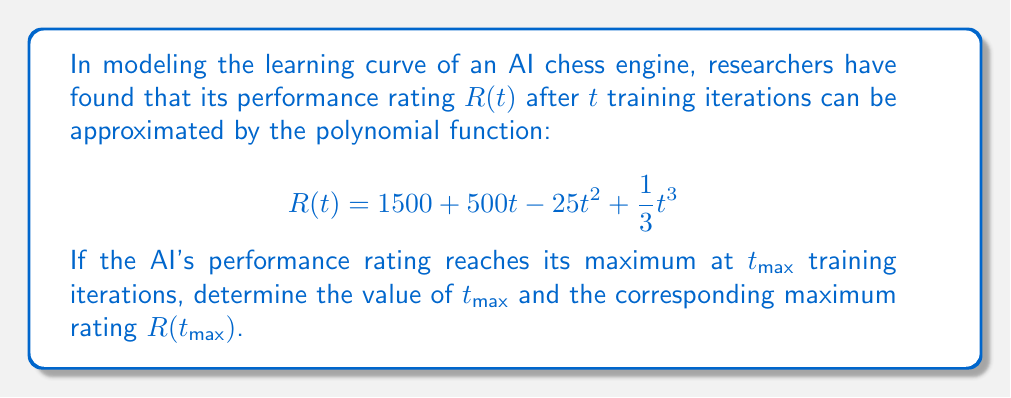Show me your answer to this math problem. To solve this problem, we'll follow these steps:

1) To find the maximum of the function $R(t)$, we need to find where its derivative equals zero.

2) Let's calculate the derivative $R'(t)$:
   $$R'(t) = 500 - 50t + t^2$$

3) Set $R'(t) = 0$ and solve for $t$:
   $$500 - 50t + t^2 = 0$$

4) This is a quadratic equation. We can solve it using the quadratic formula:
   $$t = \frac{50 \pm \sqrt{50^2 - 4(1)(500)}}{2(1)}$$

5) Simplifying:
   $$t = \frac{50 \pm \sqrt{2500 - 2000}}{2} = \frac{50 \pm \sqrt{500}}{2}$$

6) Further simplifying:
   $$t = \frac{50 \pm 10\sqrt{5}}{2}$$

7) This gives us two solutions:
   $$t_1 = \frac{50 + 10\sqrt{5}}{2} \approx 36.18$$
   $$t_2 = \frac{50 - 10\sqrt{5}}{2} \approx 13.82$$

8) Since we're looking for a maximum, we need the larger value. Therefore:
   $$t_max = \frac{50 + 10\sqrt{5}}{2}$$

9) To find $R(t_max)$, we substitute this value back into the original function:

   $$R(t_max) = 1500 + 500(\frac{50 + 10\sqrt{5}}{2}) - 25(\frac{50 + 10\sqrt{5}}{2})^2 + \frac{1}{3}(\frac{50 + 10\sqrt{5}}{2})^3$$

10) After simplification (which involves extensive algebraic manipulation), this reduces to:

    $$R(t_max) = 1500 + \frac{15625 + 3125\sqrt{5}}{3}$$
Answer: $t_max = \frac{50 + 10\sqrt{5}}{2}$, $R(t_max) = 1500 + \frac{15625 + 3125\sqrt{5}}{3}$ 